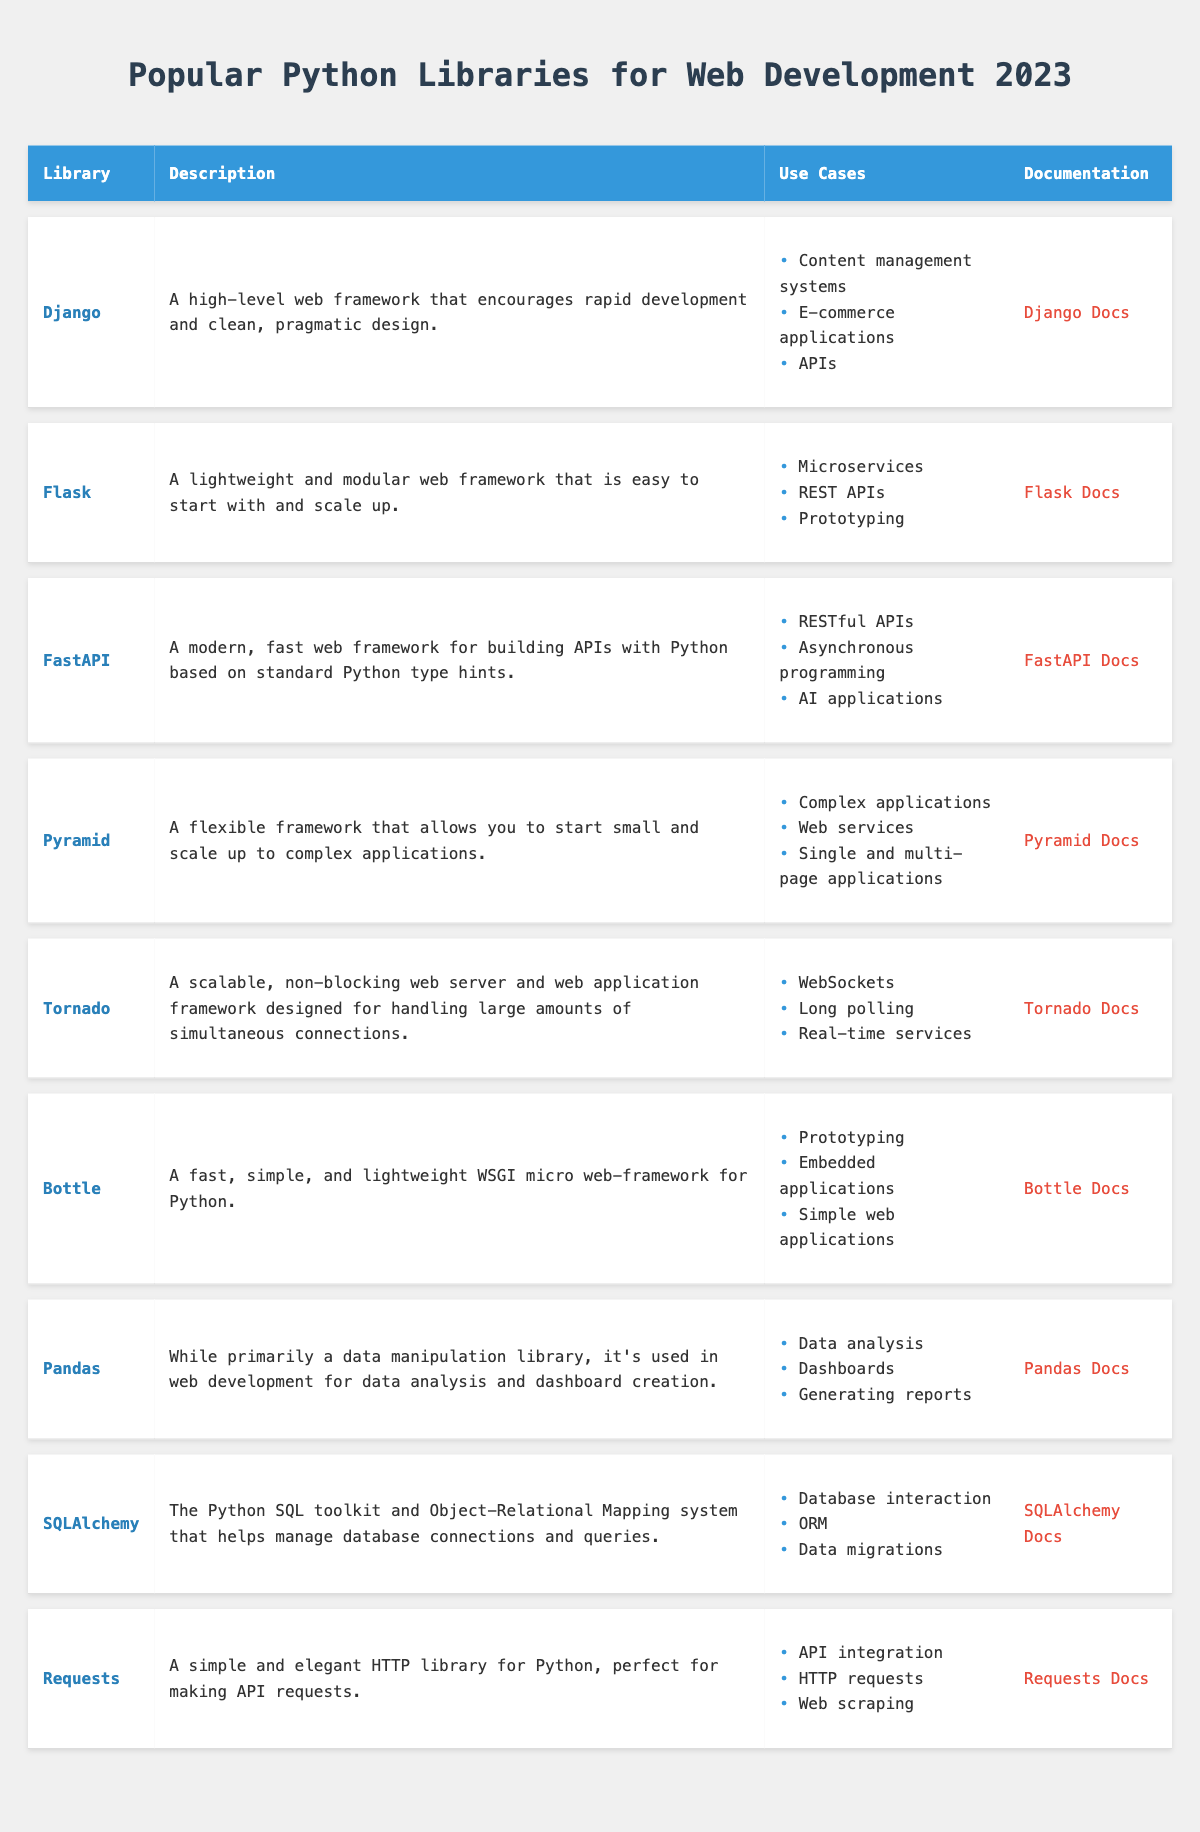What is the documentation URL for Django? The table lists Django under the "Library" column. The corresponding "Documentation" column provides the URL "https://www.djangoproject.com/" for Django.
Answer: https://www.djangoproject.com/ Which library has the use case of "WebSockets"? The table shows that Tornado has "WebSockets" listed as one of its use cases.
Answer: Tornado How many libraries are primarily frameworks for web development? The libraries that are primarily web frameworks in the table are Django, Flask, FastAPI, Pyramid, Tornado, and Bottle. Counting them gives us 6 libraries.
Answer: 6 Is FastAPI used for prototyping? Looking at the use cases listed for FastAPI, it does not include prototyping, as its focus is on RESTful APIs, asynchronous programming, and AI applications.
Answer: No Which library is used for database interaction and is also an ORM? SQLAlchemy is specifically mentioned in the table as a library that is used for "Database interaction" and is also noted as an ORM (Object-Relational Mapping system).
Answer: SQLAlchemy What is the main characteristic of the Flask library? The table notes that Flask is a "lightweight and modular web framework that is easy to start with and scale up," highlighting its simplicity and scalability.
Answer: Lightweight and modular Which two libraries are often used for creating APIs? Both Django and FastAPI are listed under the use case of APIs in the table. Thus, these libraries are commonly used for API development.
Answer: Django and FastAPI How many libraries have the release year of 2023? The table indicates that all libraries listed were released in 2023. Counting them confirms a total of 9 libraries.
Answer: 9 Is Bottle suitable for embedded applications? Yes, Bottle is listed in the table with "Embedded applications" as one of its use cases.
Answer: Yes What is the average number of use cases across all libraries mentioned? Summing all the use cases for each library from the table gives a total of 22 use cases (Django: 3 + Flask: 3 + FastAPI: 3 + Pyramid: 3 + Tornado: 3 + Bottle: 3 + Pandas: 3 + SQLAlchemy: 3 + Requests: 3 = 27). The total number of libraries is 9, so the average is 27 divided by 9, which is 3.
Answer: 3 